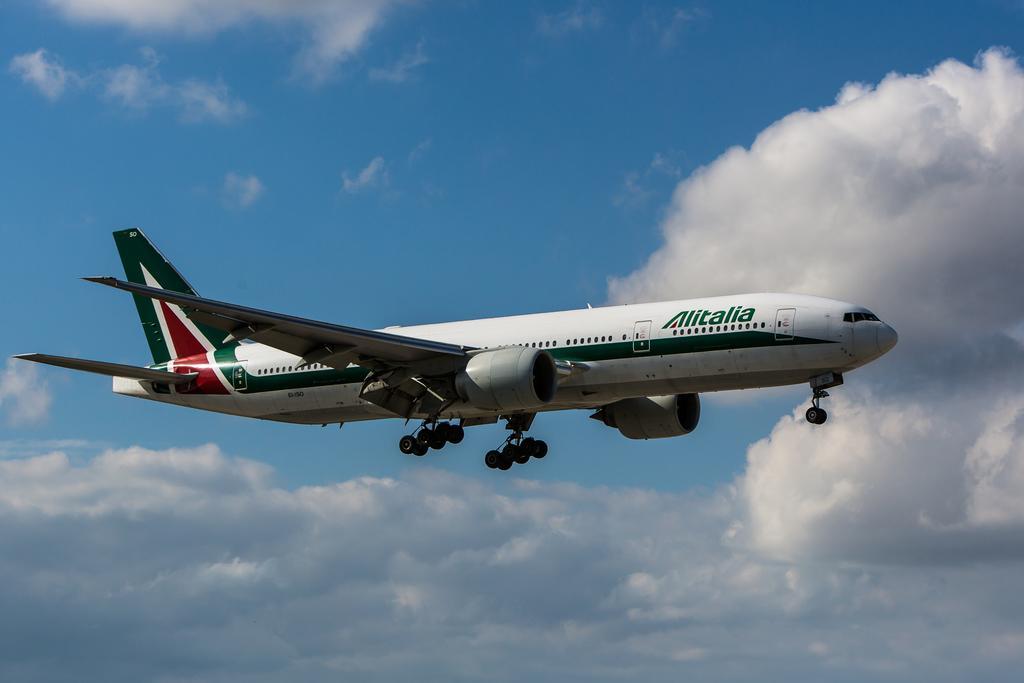How would you summarize this image in a sentence or two? In this image I can see an aircraft which is in white and green color. Background the sky is in white and blue color. 